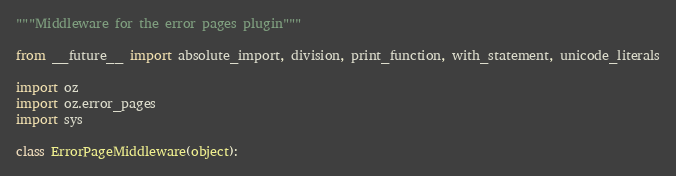Convert code to text. <code><loc_0><loc_0><loc_500><loc_500><_Python_>"""Middleware for the error pages plugin"""

from __future__ import absolute_import, division, print_function, with_statement, unicode_literals

import oz
import oz.error_pages
import sys

class ErrorPageMiddleware(object):</code> 